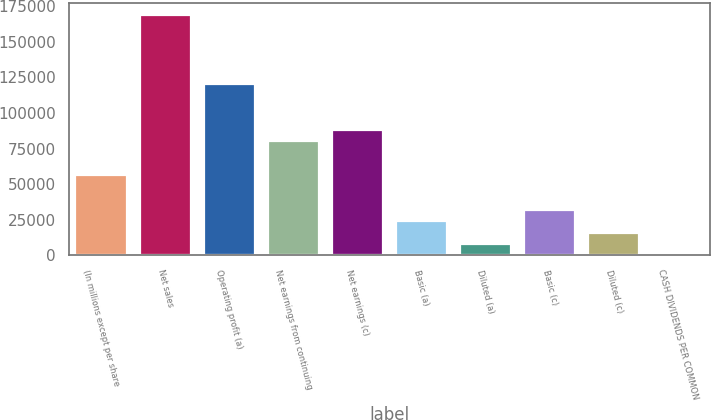Convert chart. <chart><loc_0><loc_0><loc_500><loc_500><bar_chart><fcel>(In millions except per share<fcel>Net sales<fcel>Operating profit (a)<fcel>Net earnings from continuing<fcel>Net earnings (c)<fcel>Basic (a)<fcel>Diluted (a)<fcel>Basic (c)<fcel>Diluted (c)<fcel>CASH DIVIDENDS PER COMMON<nl><fcel>56140.6<fcel>168418<fcel>120299<fcel>80200<fcel>88219.9<fcel>24061.3<fcel>8021.65<fcel>32081.1<fcel>16041.5<fcel>1.83<nl></chart> 